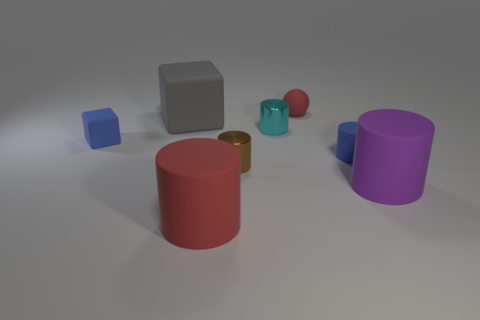There is a ball that is the same material as the purple cylinder; what is its size? The ball that shares the material characteristics with the purple cylinder appears to be small in size when compared to the larger objects in the image, such as the red cylinder and the gray cube. 